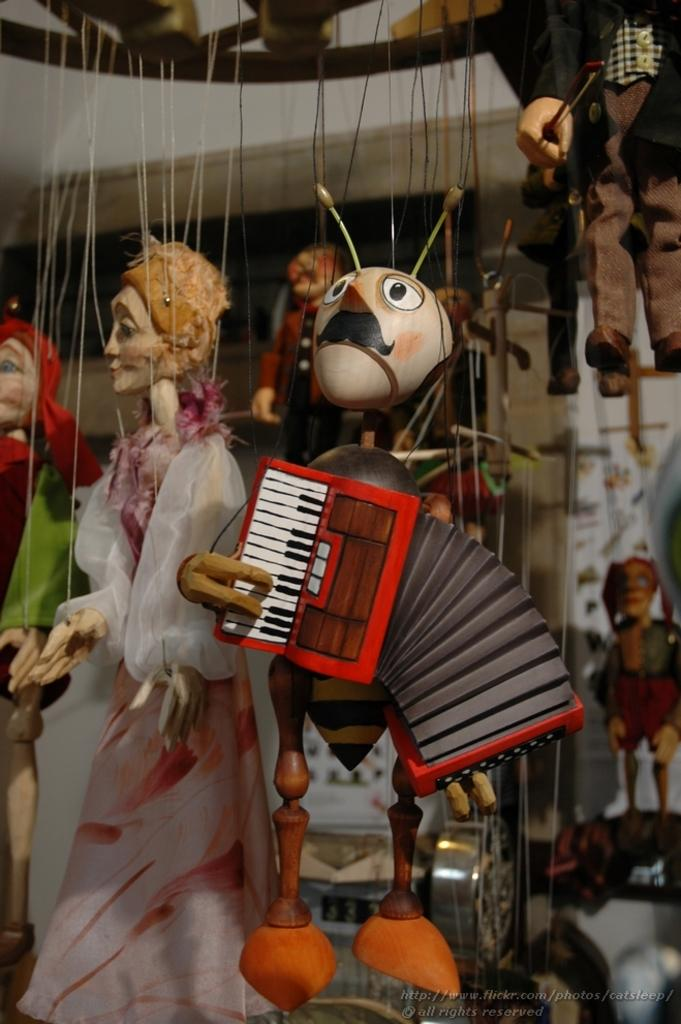What are the main subjects in the image? There are puppets in the image. Where are the puppets located in the image? The puppets are in the center of the image. What type of home can be seen in the image? There is no home present in the image; it features puppets in the center. How does the duck interact with the puppets in the image? There is no duck present in the image, so it cannot interact with the puppets. 